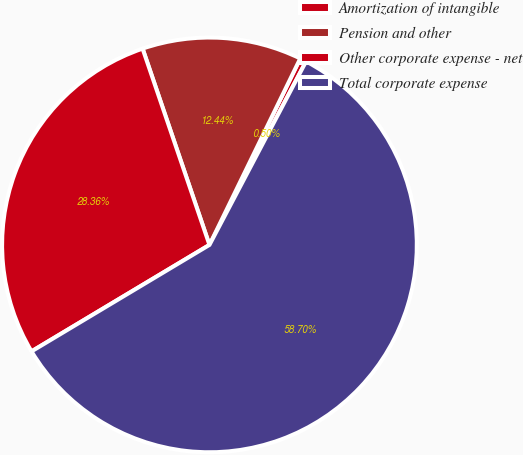<chart> <loc_0><loc_0><loc_500><loc_500><pie_chart><fcel>Amortization of intangible<fcel>Pension and other<fcel>Other corporate expense - net<fcel>Total corporate expense<nl><fcel>0.5%<fcel>12.44%<fcel>28.36%<fcel>58.71%<nl></chart> 